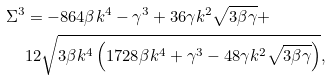Convert formula to latex. <formula><loc_0><loc_0><loc_500><loc_500>\Sigma ^ { 3 } & = - 8 6 4 \beta k ^ { 4 } - \gamma ^ { 3 } + 3 6 \gamma k ^ { 2 } \sqrt { 3 \beta \gamma } + \\ & 1 2 \sqrt { 3 \beta k ^ { 4 } \left ( 1 7 2 8 \beta k ^ { 4 } + \gamma ^ { 3 } - 4 8 \gamma k ^ { 2 } \sqrt { 3 \beta \gamma } \right ) } ,</formula> 